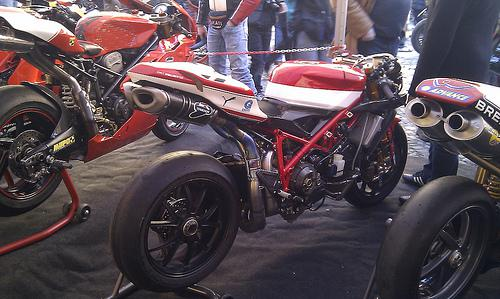Question: what color are the motorcycles?
Choices:
A. Black and white.
B. Black and red.
C. Red and white.
D. Green and white.
Answer with the letter. Answer: C Question: how many motorcycles are in the photo?
Choices:
A. Two.
B. Four.
C. Five.
D. Three.
Answer with the letter. Answer: D Question: what are the people doing in background?
Choices:
A. Looking at trucks.
B. Looking at motorcycles.
C. Looking at cars.
D. Looking at houses.
Answer with the letter. Answer: B Question: who captured this photo?
Choices:
A. Dad.
B. Mom.
C. Grandpa.
D. A photographer.
Answer with the letter. Answer: D Question: where was this photo taken?
Choices:
A. At a grocery store.
B. At a florist shop.
C. At a motorcycle shop.
D. At a gas station.
Answer with the letter. Answer: C 